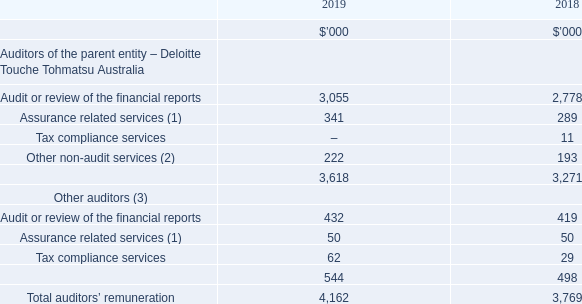This section presents the total remuneration of the Group’s external auditors for audit, assurance, and other services.
The auditors’ remuneration for the Group is as follows:
(1) Assurance related services include various agreed upon procedures and review of the sustainability report.
(2)  Other non-audit services include financial due diligence and other sundry services.
(3)  Other auditors are international associates of Deloitte Touche Tohmatsu Australia.
What is the unit used in the table? $’000. What is the total auditors' remuneration in 2019?
Answer scale should be: thousand. 4,162. What is the meaning of assurance related service in the context of the table? Assurance related services include various agreed upon procedures and review of the sustainability report. What is the difference in the total auditors' remuneration between 2018 and 2019?
Answer scale should be: thousand. 4,162 - 3,769 
Answer: 393. In 2019, what is the percentage constitution of Deloitte Touche Tohmatsu Australia's remuneration in the total auditors' remuneration?
Answer scale should be: percent. 3,618/4,162 
Answer: 86.93. For the other auditors, what is the percentage change of tax compliance service from 2018 to 2019?
Answer scale should be: percent. (62-29)/29 
Answer: 113.79. 